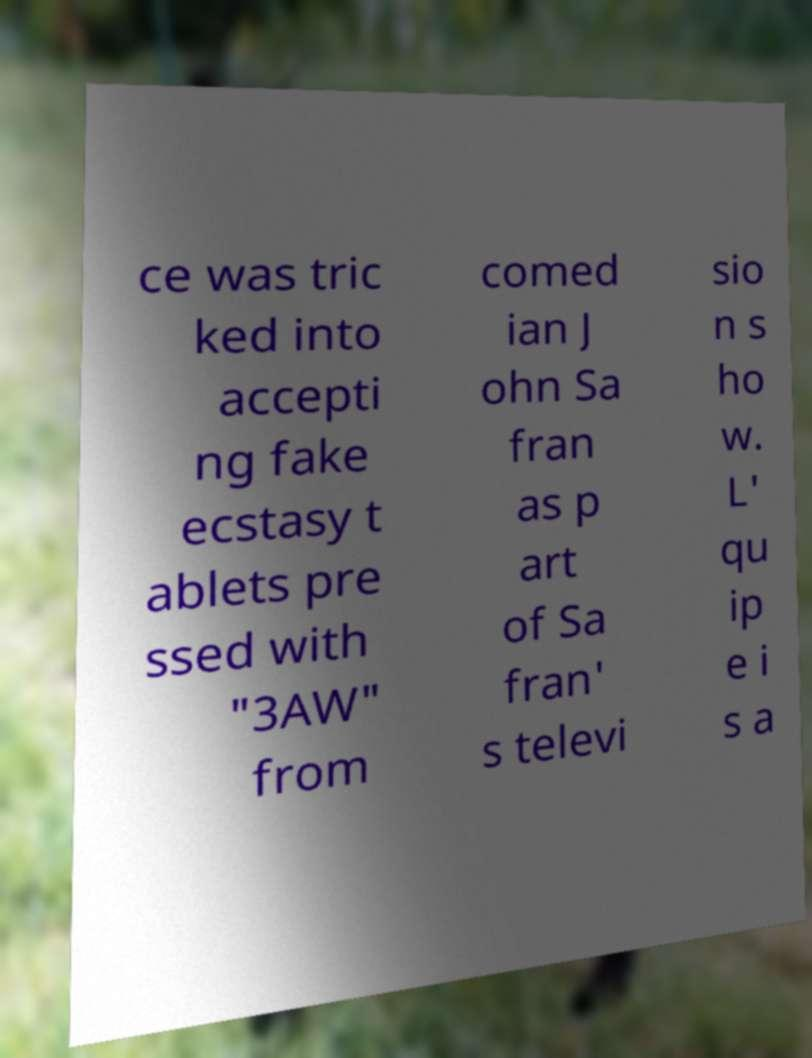Please read and relay the text visible in this image. What does it say? ce was tric ked into accepti ng fake ecstasy t ablets pre ssed with "3AW" from comed ian J ohn Sa fran as p art of Sa fran' s televi sio n s ho w. L' qu ip e i s a 